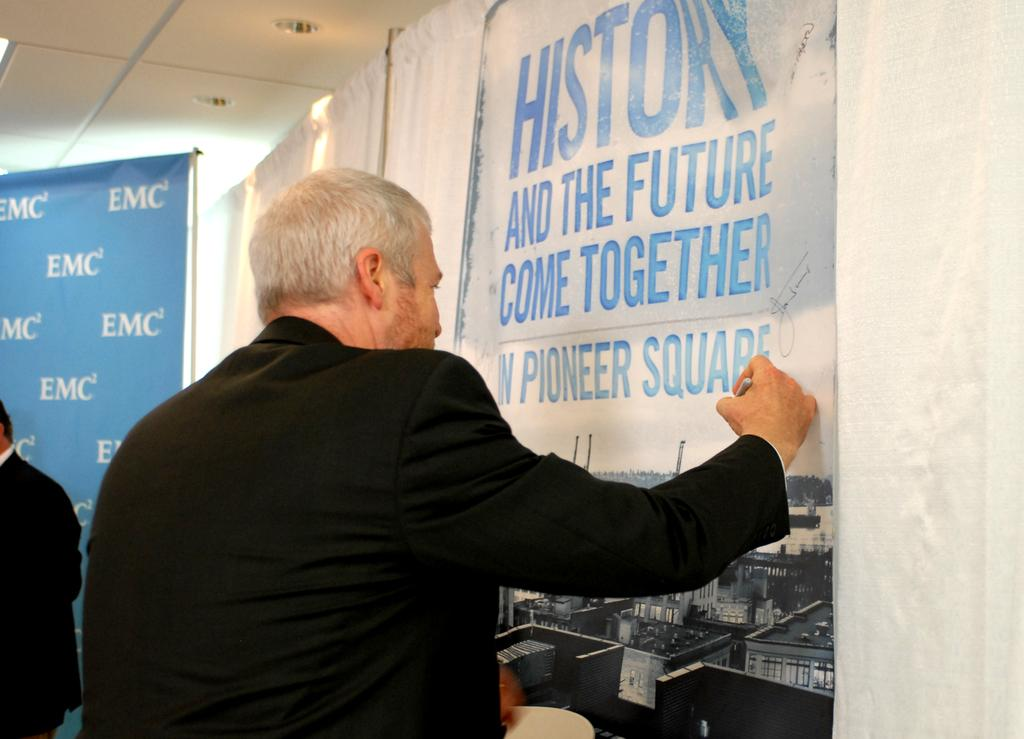<image>
Render a clear and concise summary of the photo. An older man signs a banner that pertains to an event being held in Pioneer Square. 